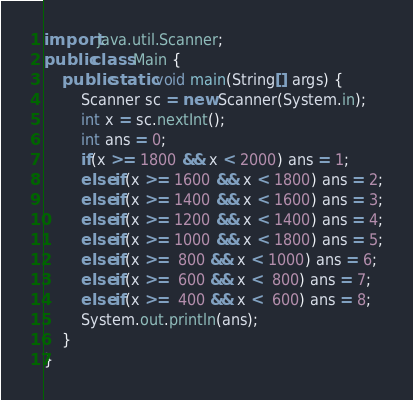Convert code to text. <code><loc_0><loc_0><loc_500><loc_500><_Java_>import java.util.Scanner;
public class Main {
    public static void main(String[] args) {
        Scanner sc = new Scanner(System.in);
        int x = sc.nextInt();
        int ans = 0;
        if(x >= 1800 && x < 2000) ans = 1;
        else if(x >= 1600 && x < 1800) ans = 2;
        else if(x >= 1400 && x < 1600) ans = 3;
        else if(x >= 1200 && x < 1400) ans = 4;
        else if(x >= 1000 && x < 1800) ans = 5;
        else if(x >=  800 && x < 1000) ans = 6;
        else if(x >=  600 && x <  800) ans = 7;
        else if(x >=  400 && x <  600) ans = 8;
        System.out.println(ans);
    }
}</code> 